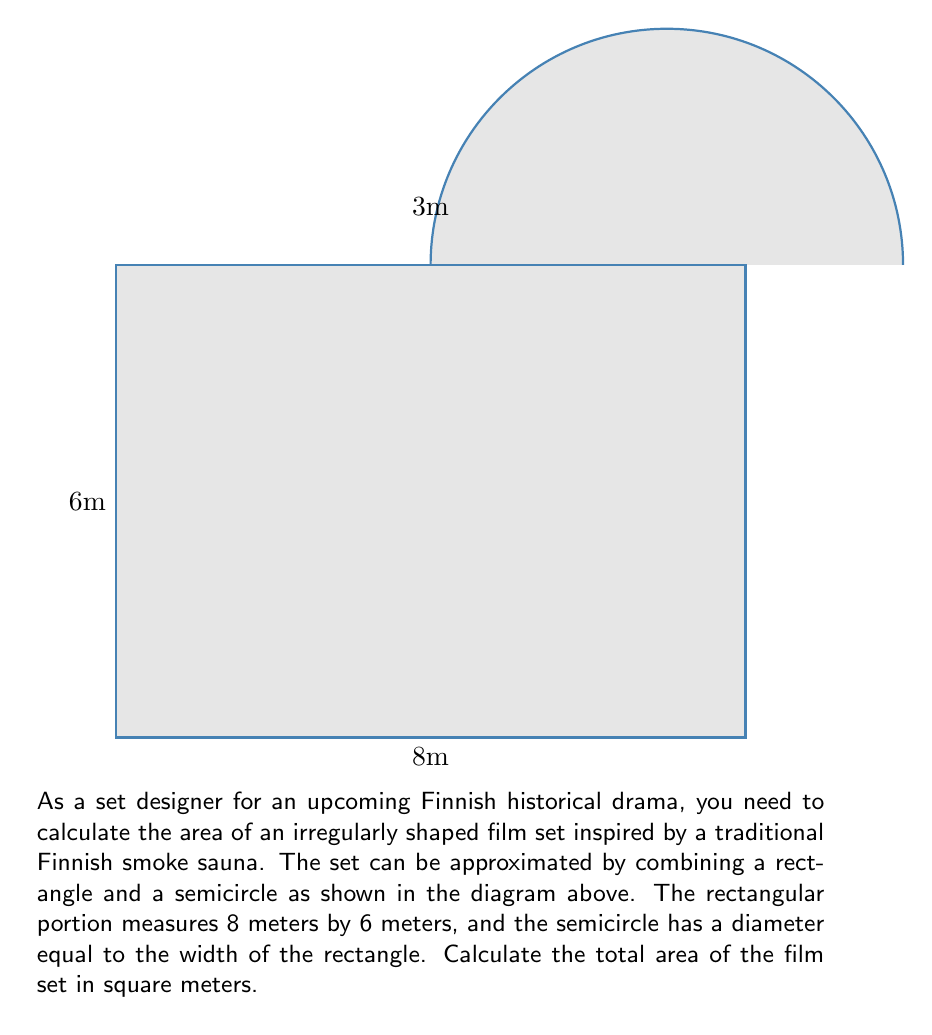What is the answer to this math problem? To calculate the total area of the film set, we need to add the areas of the rectangle and the semicircle:

1. Area of the rectangle:
   $A_{rectangle} = length \times width = 8 \text{ m} \times 6 \text{ m} = 48 \text{ m}^2$

2. Area of the semicircle:
   The diameter of the semicircle is equal to the width of the rectangle, which is 6 m.
   Therefore, the radius is 3 m.
   
   Area of a full circle: $A_{circle} = \pi r^2$
   Area of a semicircle: $A_{semicircle} = \frac{1}{2} \pi r^2$
   
   $A_{semicircle} = \frac{1}{2} \pi (3 \text{ m})^2 = \frac{9\pi}{2} \text{ m}^2 \approx 14.14 \text{ m}^2$

3. Total area of the film set:
   $A_{total} = A_{rectangle} + A_{semicircle}$
   $A_{total} = 48 \text{ m}^2 + \frac{9\pi}{2} \text{ m}^2$
   $A_{total} = 48 + \frac{9\pi}{2} \text{ m}^2 \approx 62.14 \text{ m}^2$

Therefore, the total area of the film set is $48 + \frac{9\pi}{2}$ square meters or approximately 62.14 square meters.
Answer: $48 + \frac{9\pi}{2} \text{ m}^2$ or $\approx 62.14 \text{ m}^2$ 